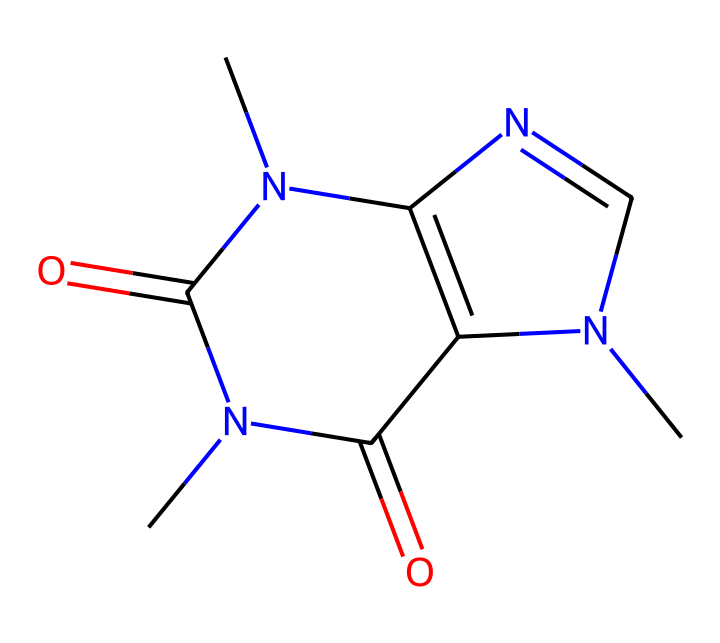how many nitrogen atoms are present in this caffeine molecule? The SMILES representation CN1C=NC2=C1C(=O)N(C(=O)N2C) indicates the presence of three nitrogen atoms based on the 'N' in the structure.
Answer: three what is the total number of rings in this chemical structure? The structure shows two fused rings, which can be identified from the 'C2=C1' and 'N1C' parts of the SMILES representation, indicating a bicyclic configuration.
Answer: two what functional groups are present in this molecule? This molecule contains carbonyl functional groups, evident from the '=O' in the structure. There are also amine groups from the nitrogen atoms.
Answer: carbonyl and amine which atom in the structure contributes to its basicity? Nitrogen atoms are known for their contribution to basicity due to their lone pair of electrons that can accept protons, which is evident in the structure.
Answer: nitrogen how does the molecular structure of caffeine influence its solubility in water? The presence of polar functional groups like the carbonyl (C=O) and nitrogen groups (N) increases the interactions with water molecules, aiding solubility.
Answer: increases what type of chemical interaction can caffeine participate in due to its structure? The polar regions of caffeine allow it to form hydrogen bonds, which are essential in various chemical interactions, such as with water.
Answer: hydrogen bonds 